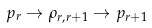<formula> <loc_0><loc_0><loc_500><loc_500>p _ { r } \rightarrow \rho _ { r , r + 1 } \rightarrow p _ { r + 1 }</formula> 